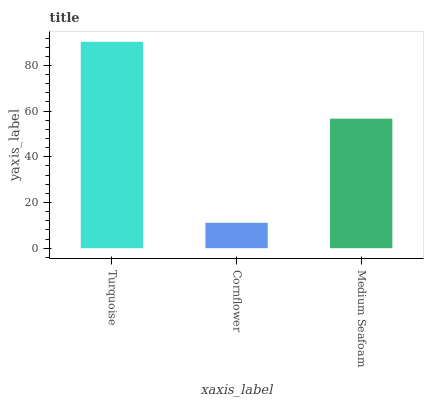Is Cornflower the minimum?
Answer yes or no. Yes. Is Turquoise the maximum?
Answer yes or no. Yes. Is Medium Seafoam the minimum?
Answer yes or no. No. Is Medium Seafoam the maximum?
Answer yes or no. No. Is Medium Seafoam greater than Cornflower?
Answer yes or no. Yes. Is Cornflower less than Medium Seafoam?
Answer yes or no. Yes. Is Cornflower greater than Medium Seafoam?
Answer yes or no. No. Is Medium Seafoam less than Cornflower?
Answer yes or no. No. Is Medium Seafoam the high median?
Answer yes or no. Yes. Is Medium Seafoam the low median?
Answer yes or no. Yes. Is Cornflower the high median?
Answer yes or no. No. Is Cornflower the low median?
Answer yes or no. No. 